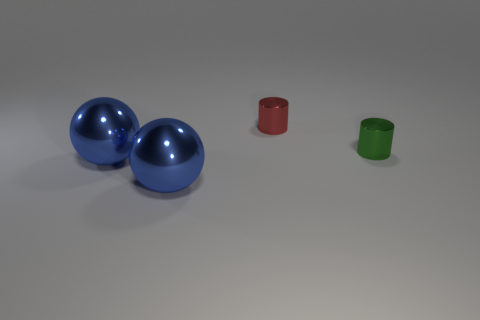Subtract all blue balls. How many were subtracted if there are1blue balls left? 1 Subtract 2 spheres. How many spheres are left? 0 Subtract all cyan spheres. Subtract all yellow cylinders. How many spheres are left? 2 Subtract all gray cubes. How many red cylinders are left? 1 Subtract all green things. Subtract all small cylinders. How many objects are left? 1 Add 1 red objects. How many red objects are left? 2 Add 4 blue metal objects. How many blue metal objects exist? 6 Add 3 metallic things. How many objects exist? 7 Subtract all red cylinders. How many cylinders are left? 1 Subtract 0 red balls. How many objects are left? 4 